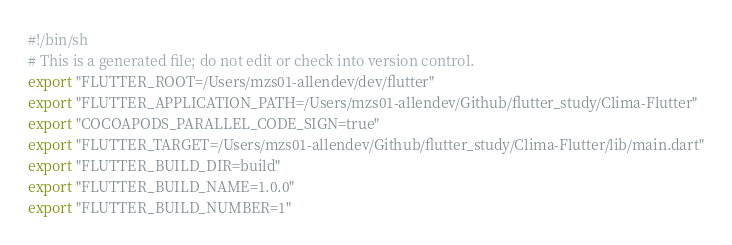<code> <loc_0><loc_0><loc_500><loc_500><_Bash_>#!/bin/sh
# This is a generated file; do not edit or check into version control.
export "FLUTTER_ROOT=/Users/mzs01-allendev/dev/flutter"
export "FLUTTER_APPLICATION_PATH=/Users/mzs01-allendev/Github/flutter_study/Clima-Flutter"
export "COCOAPODS_PARALLEL_CODE_SIGN=true"
export "FLUTTER_TARGET=/Users/mzs01-allendev/Github/flutter_study/Clima-Flutter/lib/main.dart"
export "FLUTTER_BUILD_DIR=build"
export "FLUTTER_BUILD_NAME=1.0.0"
export "FLUTTER_BUILD_NUMBER=1"</code> 